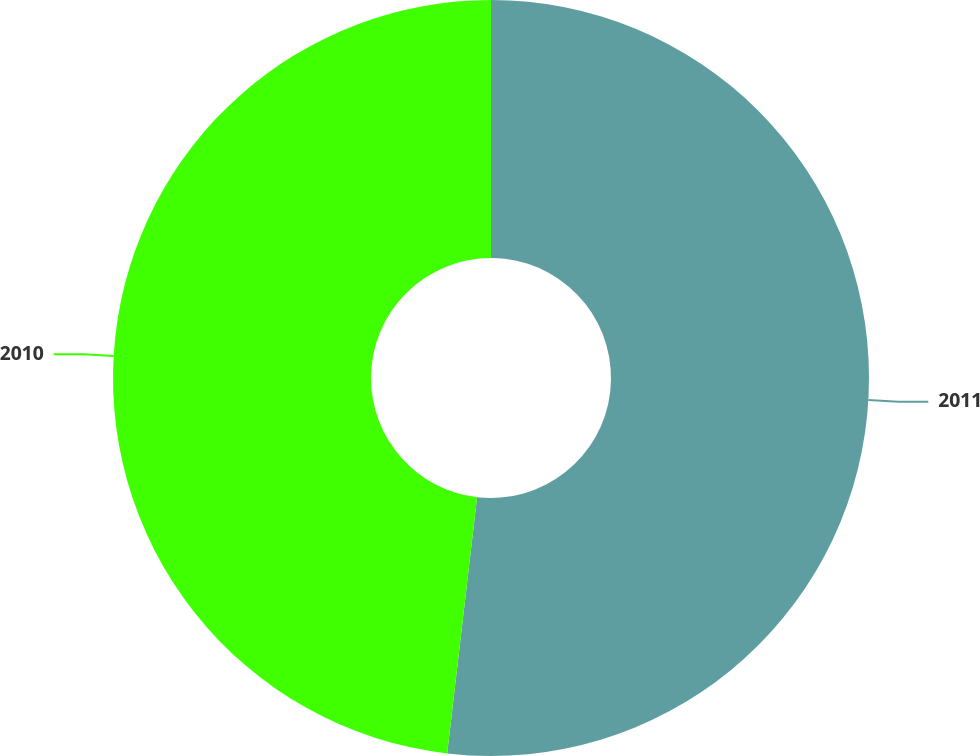<chart> <loc_0><loc_0><loc_500><loc_500><pie_chart><fcel>2011<fcel>2010<nl><fcel>51.85%<fcel>48.15%<nl></chart> 